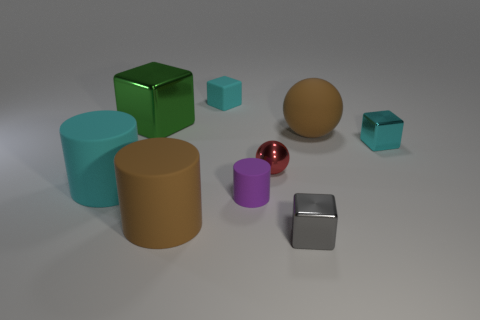Subtract all cyan cubes. How many were subtracted if there are1cyan cubes left? 1 Add 1 matte cylinders. How many objects exist? 10 Subtract all balls. How many objects are left? 7 Subtract all tiny green metallic balls. Subtract all spheres. How many objects are left? 7 Add 3 tiny purple matte things. How many tiny purple matte things are left? 4 Add 7 cylinders. How many cylinders exist? 10 Subtract 0 yellow cylinders. How many objects are left? 9 